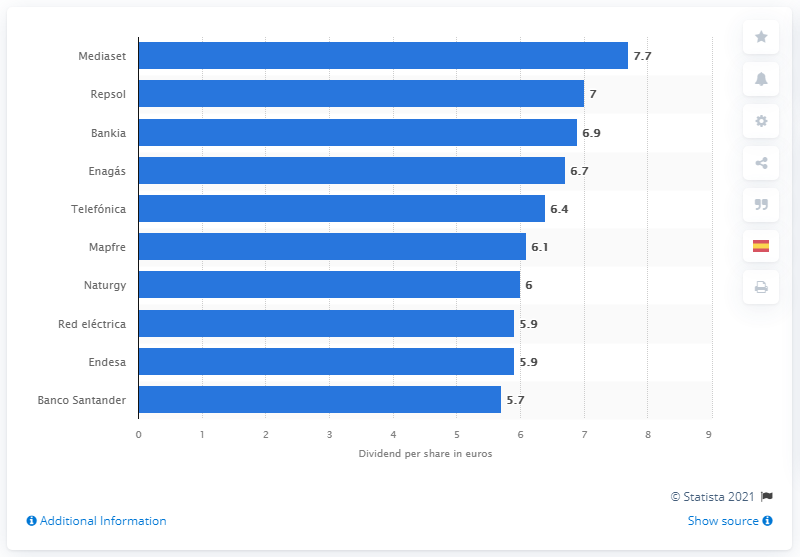List a handful of essential elements in this visual. In 2020, the Spanish stock market index had a company that had the highest gross dividend per share, which was Mediaset. Mediaset was followed by Repsol in the Spanish stock market index. 